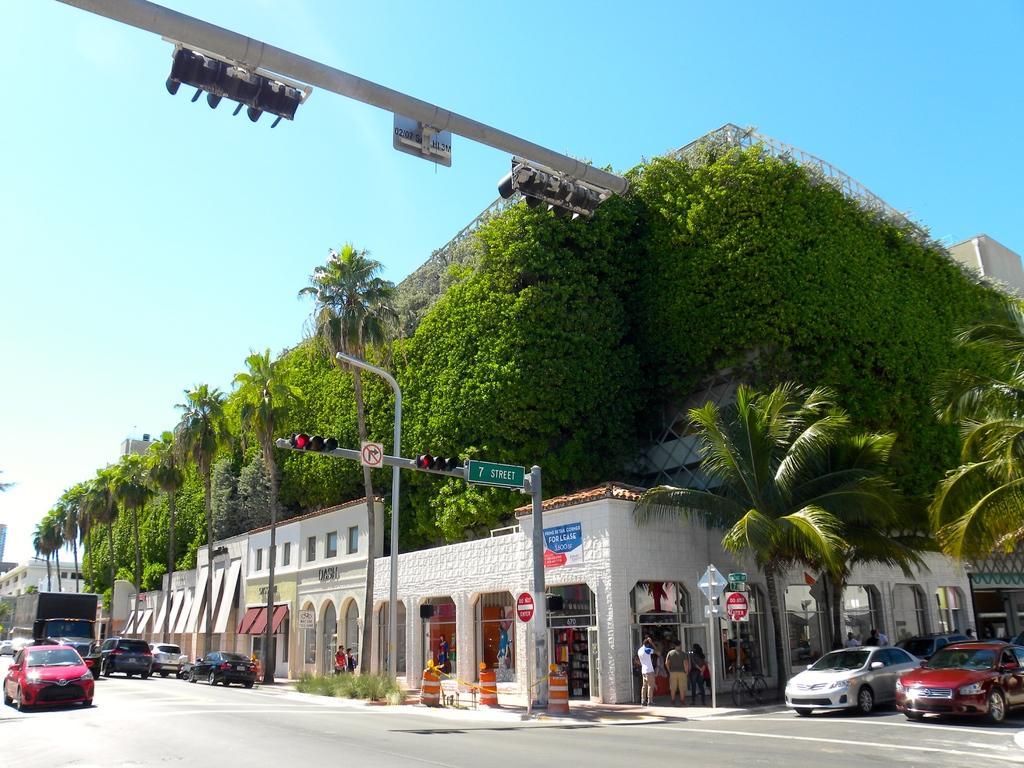Can you describe this image briefly? In this image, there are a few buildings, people, vehicles, poles, boards and signboards. We can see the ground with some objects. There are a few trees and plants. We can also see a bicycle. We can also see the sky 